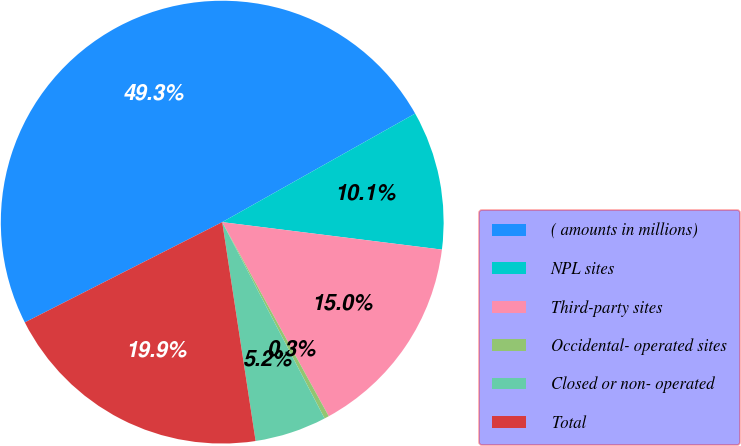Convert chart. <chart><loc_0><loc_0><loc_500><loc_500><pie_chart><fcel>( amounts in millions)<fcel>NPL sites<fcel>Third-party sites<fcel>Occidental- operated sites<fcel>Closed or non- operated<fcel>Total<nl><fcel>49.32%<fcel>10.14%<fcel>15.03%<fcel>0.34%<fcel>5.24%<fcel>19.93%<nl></chart> 